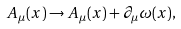Convert formula to latex. <formula><loc_0><loc_0><loc_500><loc_500>A _ { \mu } ( x ) \rightarrow A _ { \mu } ( x ) + \partial _ { \mu } \omega ( x ) ,</formula> 